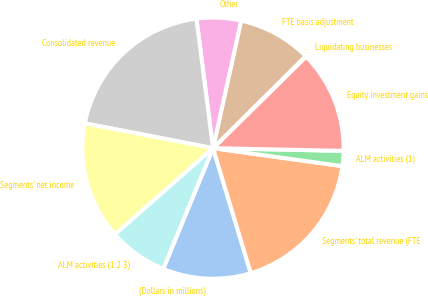Convert chart to OTSL. <chart><loc_0><loc_0><loc_500><loc_500><pie_chart><fcel>(Dollars in millions)<fcel>Segments' total revenue (FTE<fcel>ALM activities (1)<fcel>Equity investment gains<fcel>Liquidating businesses<fcel>FTE basis adjustment<fcel>Other<fcel>Consolidated revenue<fcel>Segments' net income<fcel>ALM activities (1 2 3)<nl><fcel>10.9%<fcel>18.13%<fcel>1.87%<fcel>12.71%<fcel>0.07%<fcel>9.1%<fcel>5.48%<fcel>19.93%<fcel>14.52%<fcel>7.29%<nl></chart> 